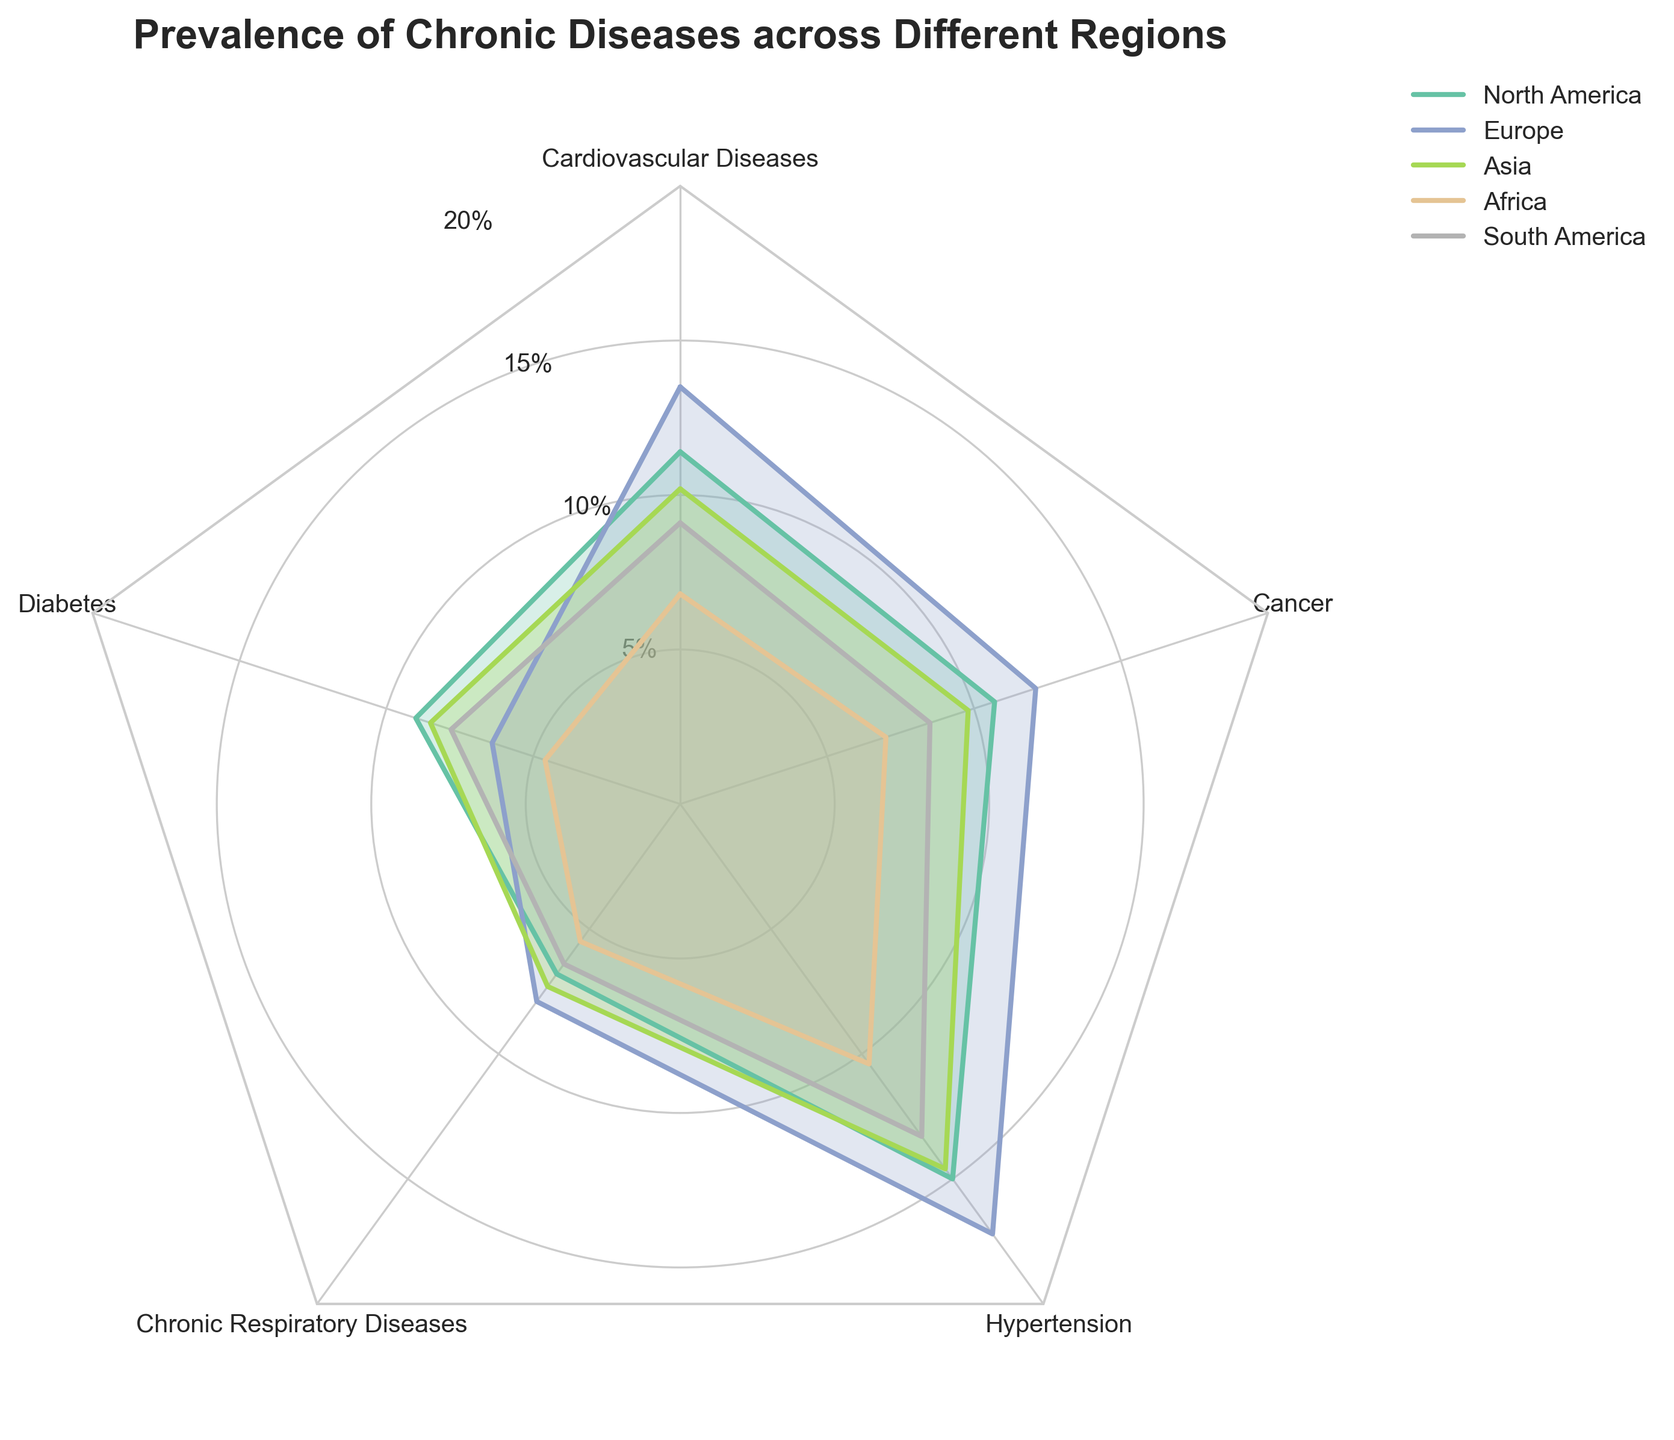What is the title of the radar chart? The title is written at the top of the radar chart, and it gives an overview of what the chart represents. In this case, it reads "Prevalence of Chronic Diseases across Different Regions".
Answer: Prevalence of Chronic Diseases across Different Regions Which region has the highest prevalence rate of Cardiovascular Diseases? To determine this, look at the Cardiovascular Diseases axis and identify which region’s line extends the farthest from the center along this axis. Europe’s line extends the farthest, indicating it has the highest prevalence rate.
Answer: Europe How does the prevalence rate of Hypertension in South America compare to Asia? Locate the Hypertension axis and compare the points for South America and Asia along this axis. South America's point is at 13.3%, while Asia's point is slightly higher at 14.6%.
Answer: Asia has a higher prevalence rate What is the range of prevalence rates for Diabetes across all the regions? Identify the Diabetes axis and find the minimum and maximum points for all regions. The lowest is 4.6% (Africa), and the highest is 9.0% (North America). The range is the difference between these two values.
Answer: Range is 4.4% Which chronic disease has the least variation in prevalence rates across different regions? To determine this, compare the spread of the points for each disease across the five regions. Cancer appears to have the least variation, with rates close to 10% across all regions.
Answer: Cancer What is the mean prevalence rate of Chronic Respiratory Diseases in North America and Africa? Locate the points for Chronic Respiratory Diseases for North America and Africa on the corresponding axis. The values are 6.8% for both regions. The mean is the sum of these values divided by 2. (6.8 + 6.8)/2 = 6.8
Answer: 6.8% Which region has the lowest prevalence rate for any chronic disease and what is the disease? Look for the smallest point on any axis. Africa has the lowest prevalence rate for Diabetes at 4.6%.
Answer: Africa, Diabetes Is the prevalence rate of Cancer higher in Europe or South America? Compare the points on the Cancer axis for Europe and South America. Europe’s point is at 12.1%, and South America’s point is at 8.5%.
Answer: Europe If a region is selected randomly, what disease is it least likely to have the highest prevalence for, and why? Examine which disease has the lowest maximum points across all regions. Diabetes and Chronic Respiratory Diseases generally have the lower max rates compared to others. Among them, Diabetes has the lowest maximum rate at 9.0% in North America.
Answer: Diabetes 